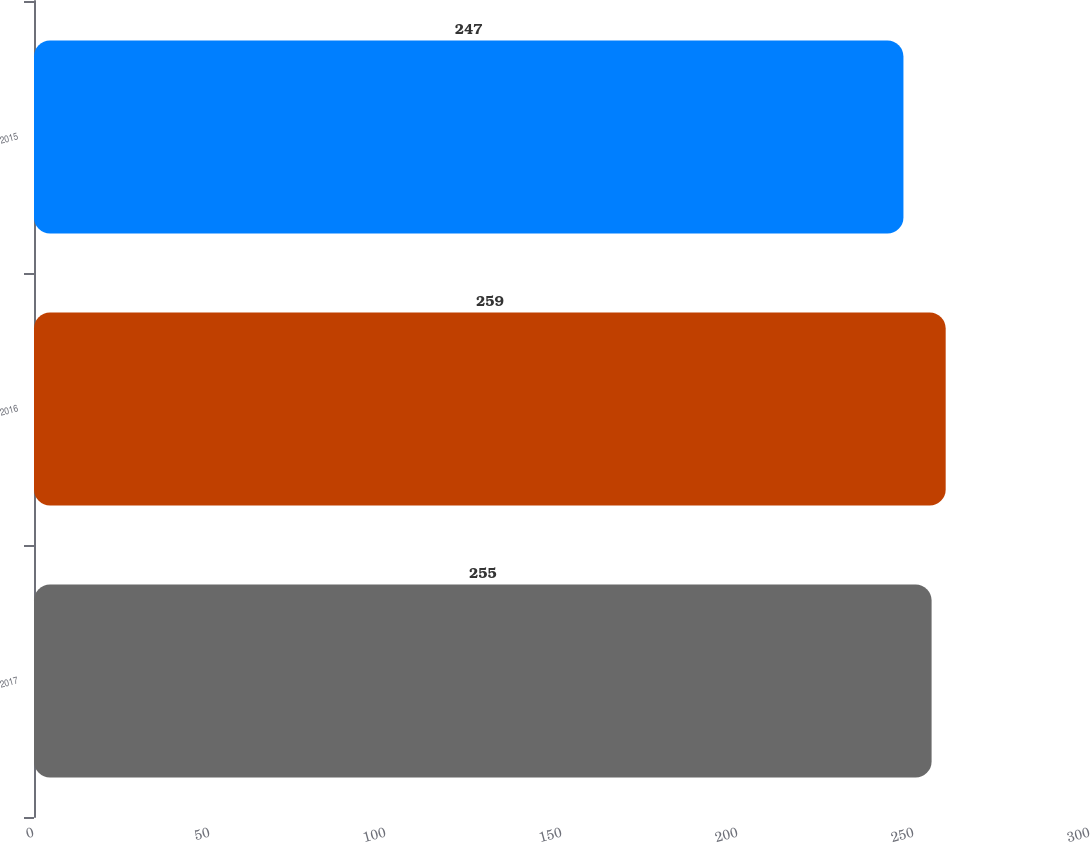<chart> <loc_0><loc_0><loc_500><loc_500><bar_chart><fcel>2017<fcel>2016<fcel>2015<nl><fcel>255<fcel>259<fcel>247<nl></chart> 